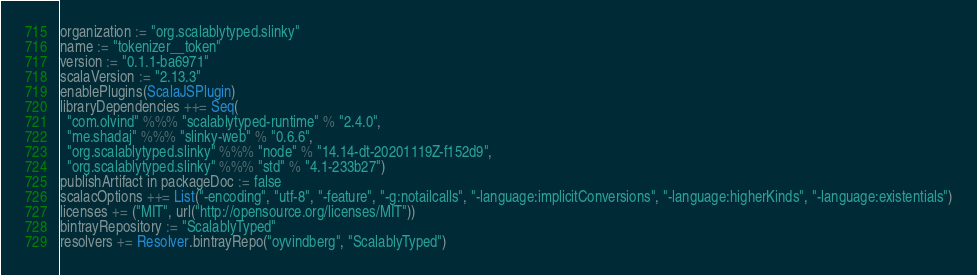Convert code to text. <code><loc_0><loc_0><loc_500><loc_500><_Scala_>organization := "org.scalablytyped.slinky"
name := "tokenizer__token"
version := "0.1.1-ba6971"
scalaVersion := "2.13.3"
enablePlugins(ScalaJSPlugin)
libraryDependencies ++= Seq(
  "com.olvind" %%% "scalablytyped-runtime" % "2.4.0",
  "me.shadaj" %%% "slinky-web" % "0.6.6",
  "org.scalablytyped.slinky" %%% "node" % "14.14-dt-20201119Z-f152d9",
  "org.scalablytyped.slinky" %%% "std" % "4.1-233b27")
publishArtifact in packageDoc := false
scalacOptions ++= List("-encoding", "utf-8", "-feature", "-g:notailcalls", "-language:implicitConversions", "-language:higherKinds", "-language:existentials")
licenses += ("MIT", url("http://opensource.org/licenses/MIT"))
bintrayRepository := "ScalablyTyped"
resolvers += Resolver.bintrayRepo("oyvindberg", "ScalablyTyped")
</code> 